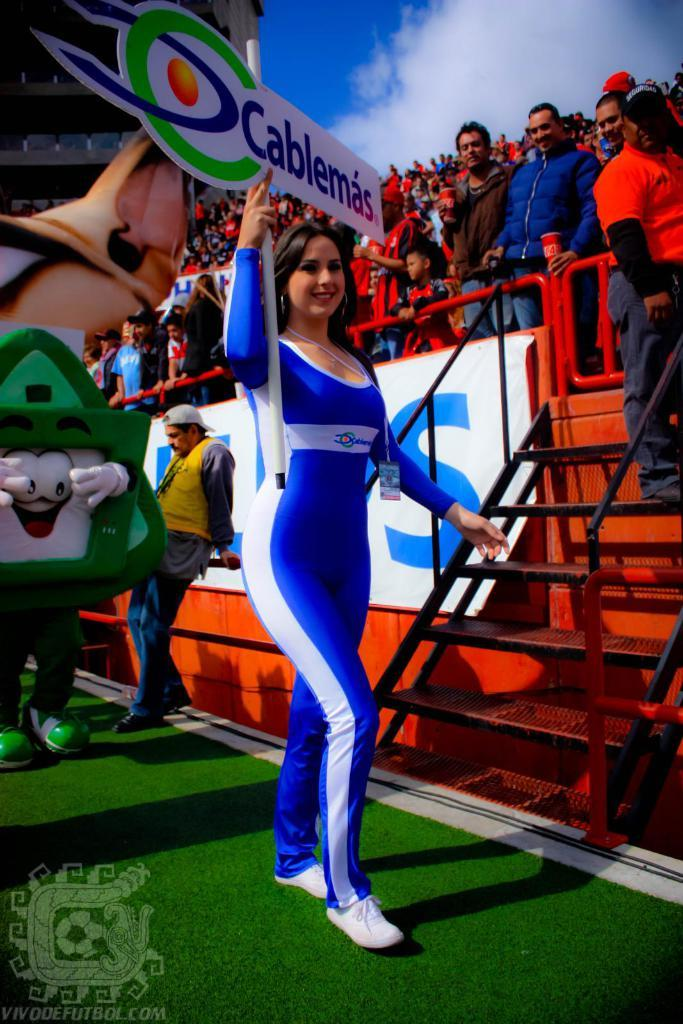<image>
Offer a succinct explanation of the picture presented. A woman in a tight jumpsuit carries a sign saying Cablemas as she walks past a crowd in a stadium. 